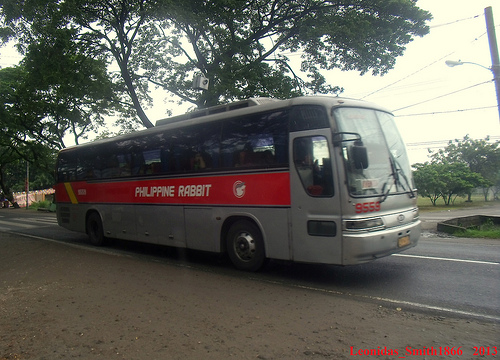<image>
Can you confirm if the bus is in front of the tree? Yes. The bus is positioned in front of the tree, appearing closer to the camera viewpoint. 